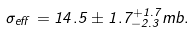<formula> <loc_0><loc_0><loc_500><loc_500>\sigma _ { e f f } = 1 4 . 5 \pm 1 . 7 ^ { + 1 . 7 } _ { - 2 . 3 } m b .</formula> 